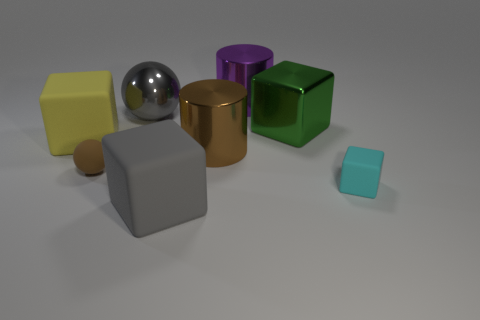Subtract all small matte blocks. How many blocks are left? 3 Subtract all cyan cubes. How many cubes are left? 3 Subtract all brown cubes. Subtract all cyan cylinders. How many cubes are left? 4 Add 1 tiny brown metallic cubes. How many objects exist? 9 Subtract all balls. How many objects are left? 6 Add 7 small brown balls. How many small brown balls exist? 8 Subtract 0 brown blocks. How many objects are left? 8 Subtract all large blocks. Subtract all gray metal things. How many objects are left? 4 Add 8 green blocks. How many green blocks are left? 9 